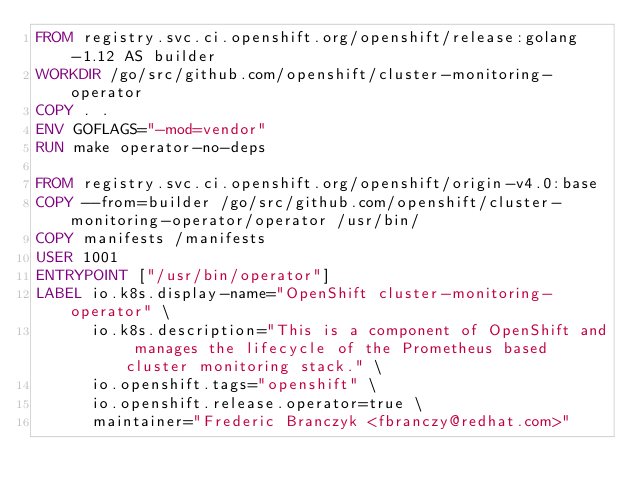<code> <loc_0><loc_0><loc_500><loc_500><_Dockerfile_>FROM registry.svc.ci.openshift.org/openshift/release:golang-1.12 AS builder
WORKDIR /go/src/github.com/openshift/cluster-monitoring-operator
COPY . .
ENV GOFLAGS="-mod=vendor"
RUN make operator-no-deps

FROM registry.svc.ci.openshift.org/openshift/origin-v4.0:base
COPY --from=builder /go/src/github.com/openshift/cluster-monitoring-operator/operator /usr/bin/
COPY manifests /manifests
USER 1001
ENTRYPOINT ["/usr/bin/operator"]
LABEL io.k8s.display-name="OpenShift cluster-monitoring-operator" \
      io.k8s.description="This is a component of OpenShift and manages the lifecycle of the Prometheus based cluster monitoring stack." \
      io.openshift.tags="openshift" \
      io.openshift.release.operator=true \
      maintainer="Frederic Branczyk <fbranczy@redhat.com>"
</code> 